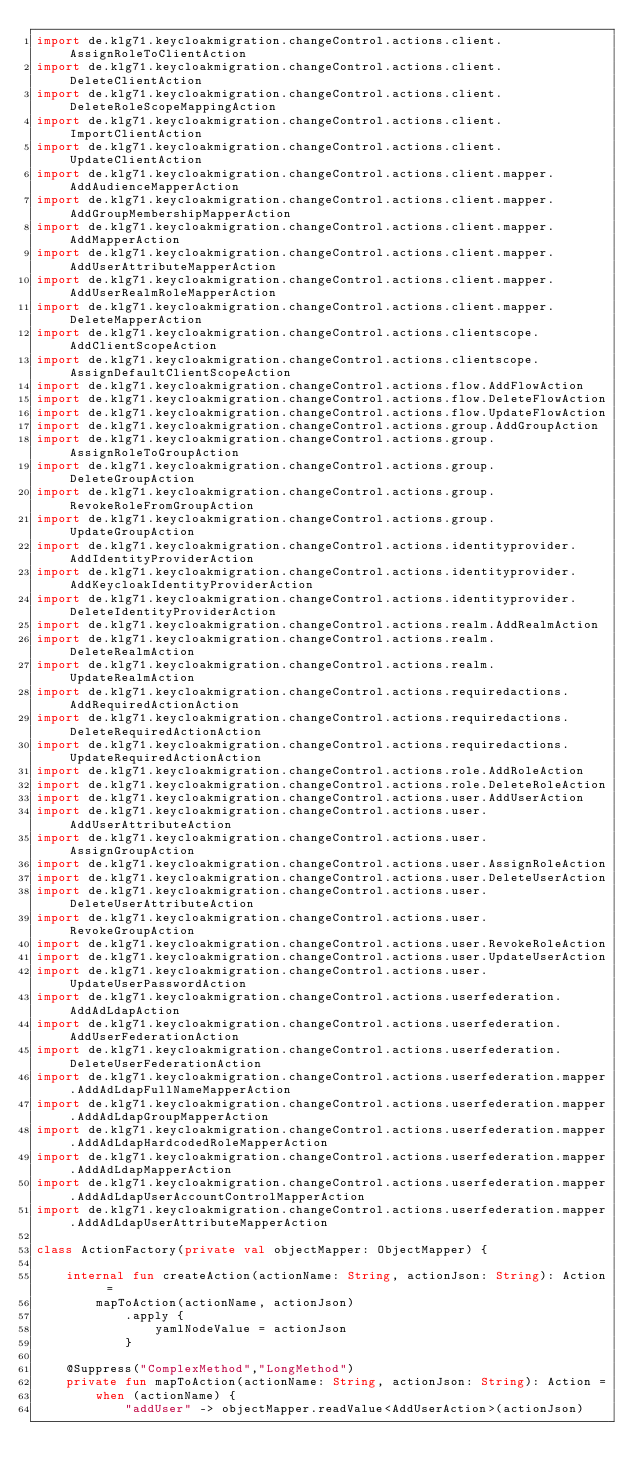Convert code to text. <code><loc_0><loc_0><loc_500><loc_500><_Kotlin_>import de.klg71.keycloakmigration.changeControl.actions.client.AssignRoleToClientAction
import de.klg71.keycloakmigration.changeControl.actions.client.DeleteClientAction
import de.klg71.keycloakmigration.changeControl.actions.client.DeleteRoleScopeMappingAction
import de.klg71.keycloakmigration.changeControl.actions.client.ImportClientAction
import de.klg71.keycloakmigration.changeControl.actions.client.UpdateClientAction
import de.klg71.keycloakmigration.changeControl.actions.client.mapper.AddAudienceMapperAction
import de.klg71.keycloakmigration.changeControl.actions.client.mapper.AddGroupMembershipMapperAction
import de.klg71.keycloakmigration.changeControl.actions.client.mapper.AddMapperAction
import de.klg71.keycloakmigration.changeControl.actions.client.mapper.AddUserAttributeMapperAction
import de.klg71.keycloakmigration.changeControl.actions.client.mapper.AddUserRealmRoleMapperAction
import de.klg71.keycloakmigration.changeControl.actions.client.mapper.DeleteMapperAction
import de.klg71.keycloakmigration.changeControl.actions.clientscope.AddClientScopeAction
import de.klg71.keycloakmigration.changeControl.actions.clientscope.AssignDefaultClientScopeAction
import de.klg71.keycloakmigration.changeControl.actions.flow.AddFlowAction
import de.klg71.keycloakmigration.changeControl.actions.flow.DeleteFlowAction
import de.klg71.keycloakmigration.changeControl.actions.flow.UpdateFlowAction
import de.klg71.keycloakmigration.changeControl.actions.group.AddGroupAction
import de.klg71.keycloakmigration.changeControl.actions.group.AssignRoleToGroupAction
import de.klg71.keycloakmigration.changeControl.actions.group.DeleteGroupAction
import de.klg71.keycloakmigration.changeControl.actions.group.RevokeRoleFromGroupAction
import de.klg71.keycloakmigration.changeControl.actions.group.UpdateGroupAction
import de.klg71.keycloakmigration.changeControl.actions.identityprovider.AddIdentityProviderAction
import de.klg71.keycloakmigration.changeControl.actions.identityprovider.AddKeycloakIdentityProviderAction
import de.klg71.keycloakmigration.changeControl.actions.identityprovider.DeleteIdentityProviderAction
import de.klg71.keycloakmigration.changeControl.actions.realm.AddRealmAction
import de.klg71.keycloakmigration.changeControl.actions.realm.DeleteRealmAction
import de.klg71.keycloakmigration.changeControl.actions.realm.UpdateRealmAction
import de.klg71.keycloakmigration.changeControl.actions.requiredactions.AddRequiredActionAction
import de.klg71.keycloakmigration.changeControl.actions.requiredactions.DeleteRequiredActionAction
import de.klg71.keycloakmigration.changeControl.actions.requiredactions.UpdateRequiredActionAction
import de.klg71.keycloakmigration.changeControl.actions.role.AddRoleAction
import de.klg71.keycloakmigration.changeControl.actions.role.DeleteRoleAction
import de.klg71.keycloakmigration.changeControl.actions.user.AddUserAction
import de.klg71.keycloakmigration.changeControl.actions.user.AddUserAttributeAction
import de.klg71.keycloakmigration.changeControl.actions.user.AssignGroupAction
import de.klg71.keycloakmigration.changeControl.actions.user.AssignRoleAction
import de.klg71.keycloakmigration.changeControl.actions.user.DeleteUserAction
import de.klg71.keycloakmigration.changeControl.actions.user.DeleteUserAttributeAction
import de.klg71.keycloakmigration.changeControl.actions.user.RevokeGroupAction
import de.klg71.keycloakmigration.changeControl.actions.user.RevokeRoleAction
import de.klg71.keycloakmigration.changeControl.actions.user.UpdateUserAction
import de.klg71.keycloakmigration.changeControl.actions.user.UpdateUserPasswordAction
import de.klg71.keycloakmigration.changeControl.actions.userfederation.AddAdLdapAction
import de.klg71.keycloakmigration.changeControl.actions.userfederation.AddUserFederationAction
import de.klg71.keycloakmigration.changeControl.actions.userfederation.DeleteUserFederationAction
import de.klg71.keycloakmigration.changeControl.actions.userfederation.mapper.AddAdLdapFullNameMapperAction
import de.klg71.keycloakmigration.changeControl.actions.userfederation.mapper.AddAdLdapGroupMapperAction
import de.klg71.keycloakmigration.changeControl.actions.userfederation.mapper.AddAdLdapHardcodedRoleMapperAction
import de.klg71.keycloakmigration.changeControl.actions.userfederation.mapper.AddAdLdapMapperAction
import de.klg71.keycloakmigration.changeControl.actions.userfederation.mapper.AddAdLdapUserAccountControlMapperAction
import de.klg71.keycloakmigration.changeControl.actions.userfederation.mapper.AddAdLdapUserAttributeMapperAction

class ActionFactory(private val objectMapper: ObjectMapper) {

    internal fun createAction(actionName: String, actionJson: String): Action =
        mapToAction(actionName, actionJson)
            .apply {
                yamlNodeValue = actionJson
            }

    @Suppress("ComplexMethod","LongMethod")
    private fun mapToAction(actionName: String, actionJson: String): Action =
        when (actionName) {
            "addUser" -> objectMapper.readValue<AddUserAction>(actionJson)</code> 